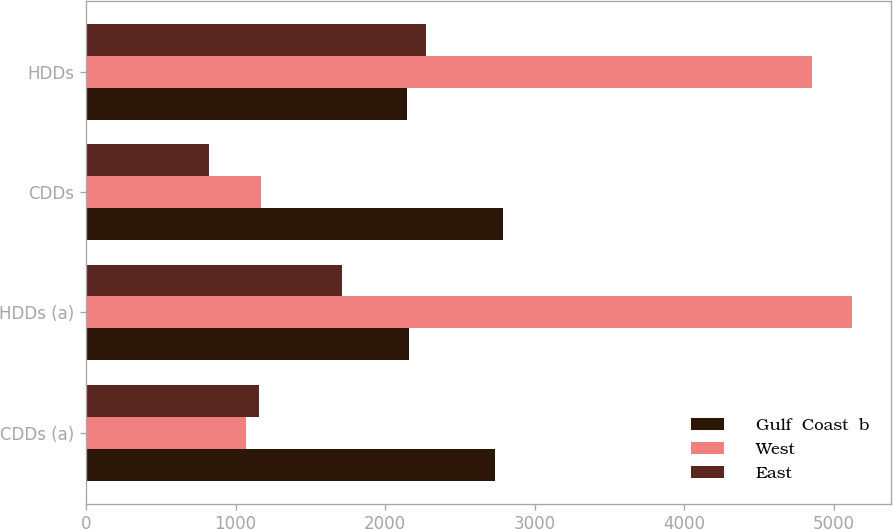Convert chart to OTSL. <chart><loc_0><loc_0><loc_500><loc_500><stacked_bar_chart><ecel><fcel>CDDs (a)<fcel>HDDs (a)<fcel>CDDs<fcel>HDDs<nl><fcel>Gulf  Coast  b<fcel>2737<fcel>2157<fcel>2787<fcel>2148<nl><fcel>West<fcel>1068<fcel>5123<fcel>1173<fcel>4852<nl><fcel>East<fcel>1158<fcel>1712<fcel>819<fcel>2272<nl></chart> 